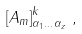Convert formula to latex. <formula><loc_0><loc_0><loc_500><loc_500>\left [ A _ { m } \right ] ^ { k } _ { \alpha _ { 1 } \dots \alpha _ { z } } \, ,</formula> 